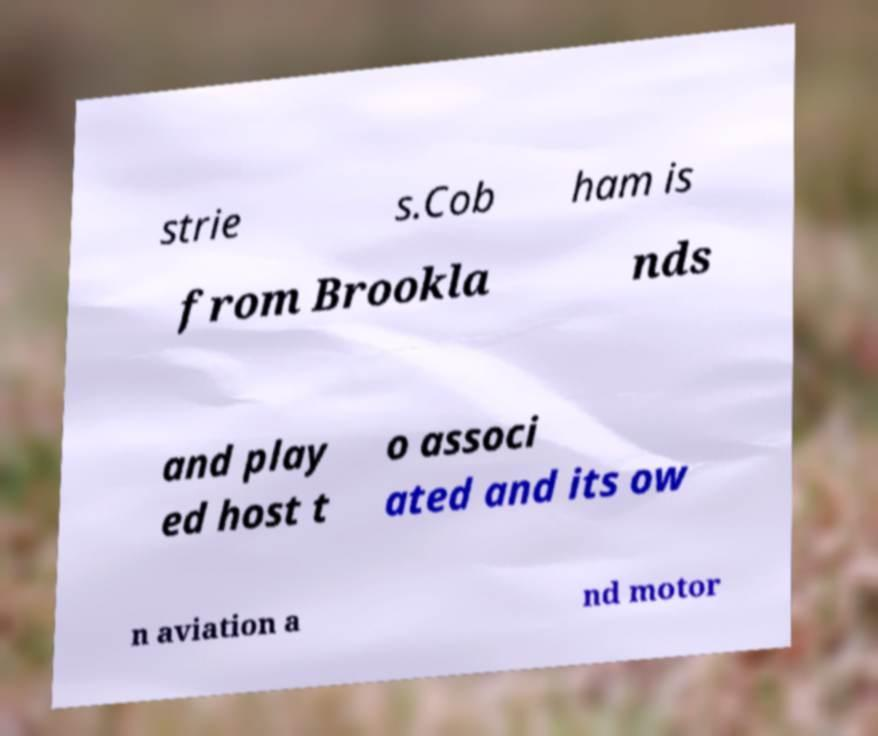Please read and relay the text visible in this image. What does it say? strie s.Cob ham is from Brookla nds and play ed host t o associ ated and its ow n aviation a nd motor 